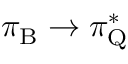<formula> <loc_0><loc_0><loc_500><loc_500>\pi _ { B } \rightarrow \pi _ { Q } ^ { * }</formula> 